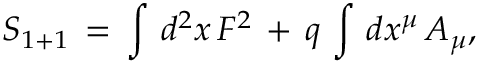<formula> <loc_0><loc_0><loc_500><loc_500>S _ { 1 + 1 } \, = \, \int \, d ^ { 2 } x \, F ^ { 2 } \, + \, q \, \int \, d x ^ { \mu } \, A _ { \mu } ,</formula> 